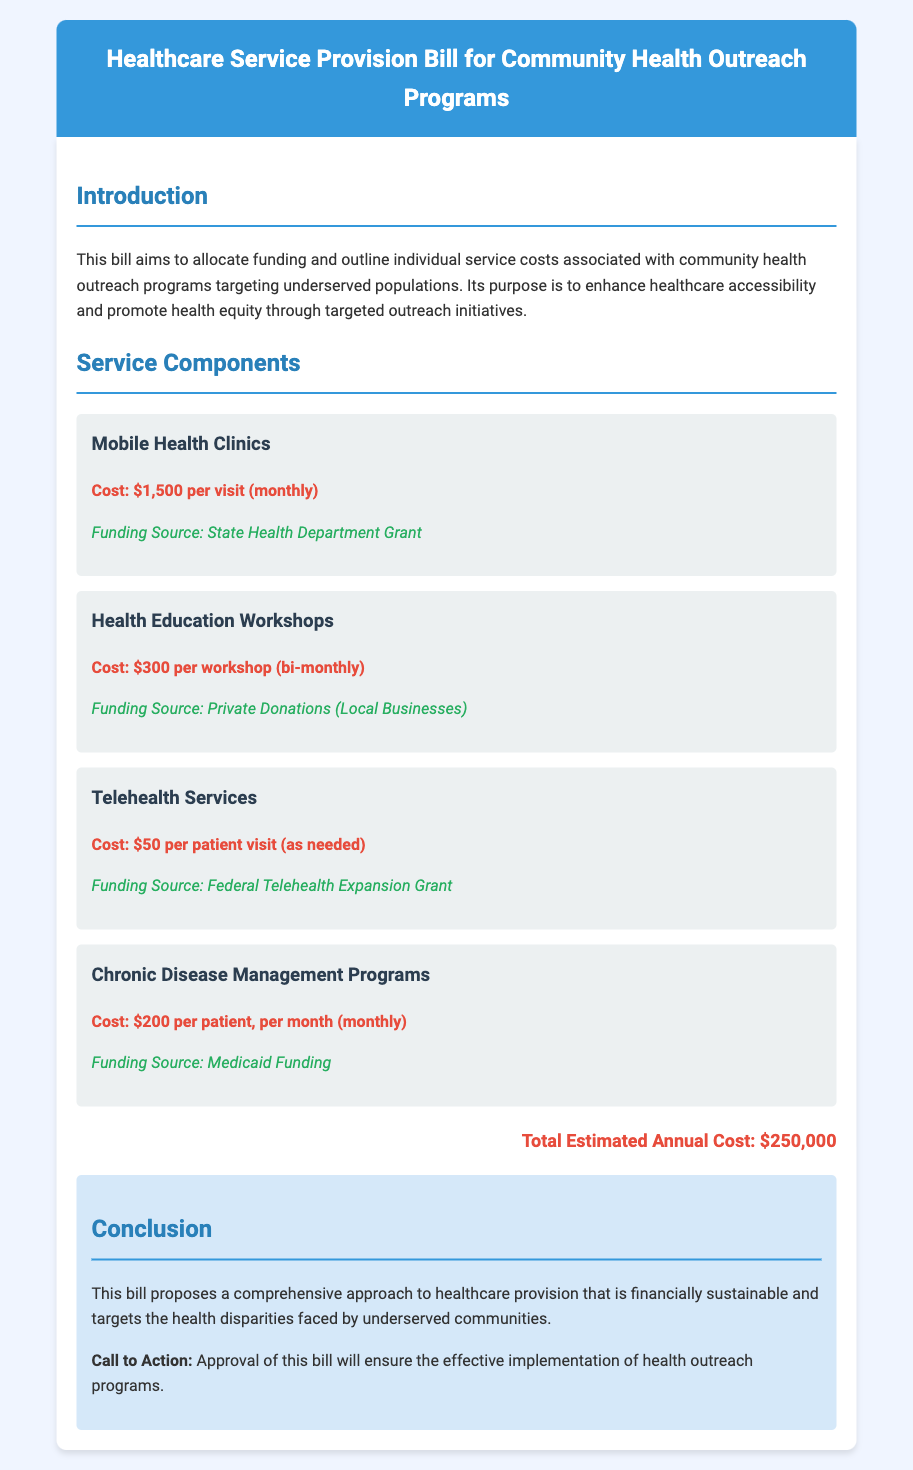What is the purpose of this bill? The purpose is to enhance healthcare accessibility and promote health equity through targeted outreach initiatives.
Answer: To enhance healthcare accessibility and promote health equity What is the cost for a mobile health clinic visit? The cost for a mobile health clinic visit is explicitly stated in the document.
Answer: $1,500 per visit What is the funding source for health education workshops? The document specifies that the funding source for health education workshops comes from local businesses.
Answer: Private Donations (Local Businesses) How often are telehealth services provided? The frequency of telehealth services is mentioned as needed in the document.
Answer: As needed What is the total estimated annual cost? The total estimated annual cost is directly provided in the document.
Answer: $250,000 What type of programs does the bill propose for chronic disease management? The document specifically describes the initiatives related to chronic disease management.
Answer: Chronic Disease Management Programs What is the cost per patient for chronic disease management? The document provides the explicit cost per patient for chronic disease management programs.
Answer: $200 per patient, per month What are the mobile health clinics primarily funded by? The funding source for mobile health clinics is mentioned in the document.
Answer: State Health Department Grant What is the conclusion's call to action? The call to action in the conclusion section is clearly articulated in the document.
Answer: Approval of this bill will ensure the effective implementation of health outreach programs 